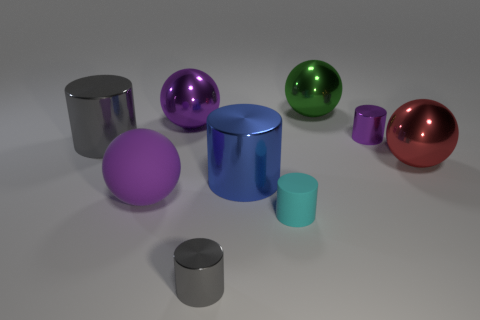There is a purple metallic thing to the right of the big purple ball that is right of the large purple matte sphere; what is its shape?
Provide a succinct answer. Cylinder. Is there any other thing that is the same color as the rubber cylinder?
Make the answer very short. No. How many red objects are either large metallic balls or objects?
Keep it short and to the point. 1. Are there fewer green things right of the purple shiny cylinder than small gray shiny cylinders?
Keep it short and to the point. Yes. How many tiny shiny cylinders are behind the ball right of the tiny purple cylinder?
Your answer should be compact. 1. How many other things are the same size as the blue thing?
Ensure brevity in your answer.  5. How many things are small yellow metal objects or objects right of the big matte thing?
Ensure brevity in your answer.  7. Are there fewer tiny purple metal cylinders than large gray shiny balls?
Your answer should be compact. No. What is the color of the large cylinder that is left of the purple ball behind the matte ball?
Offer a very short reply. Gray. What is the material of the cyan thing that is the same shape as the blue shiny object?
Provide a short and direct response. Rubber. 